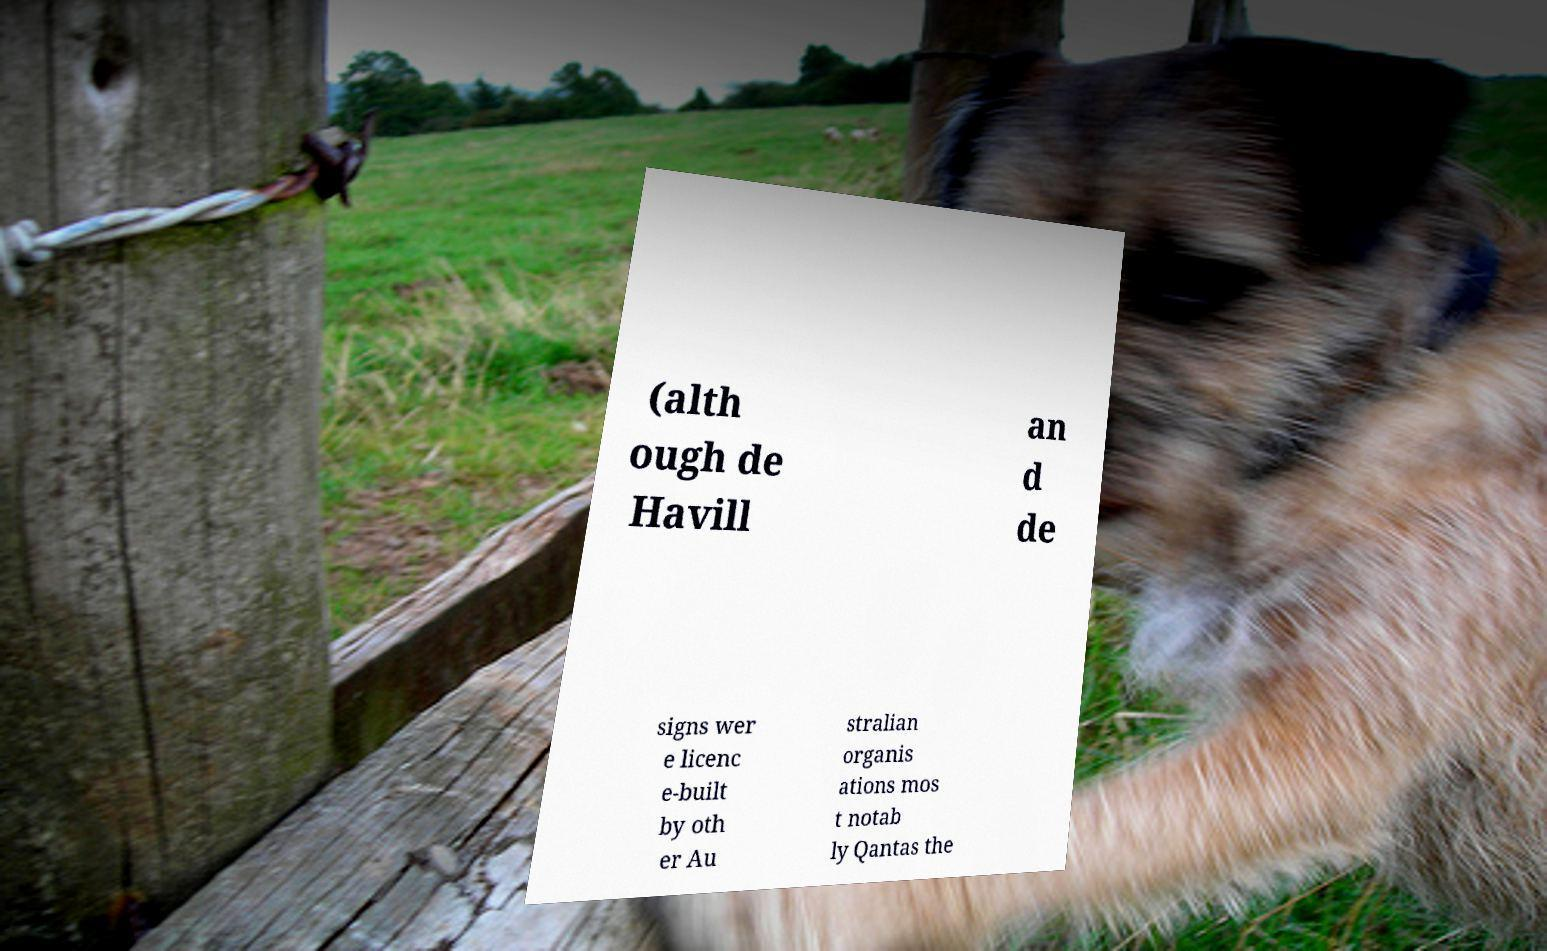I need the written content from this picture converted into text. Can you do that? (alth ough de Havill an d de signs wer e licenc e-built by oth er Au stralian organis ations mos t notab ly Qantas the 